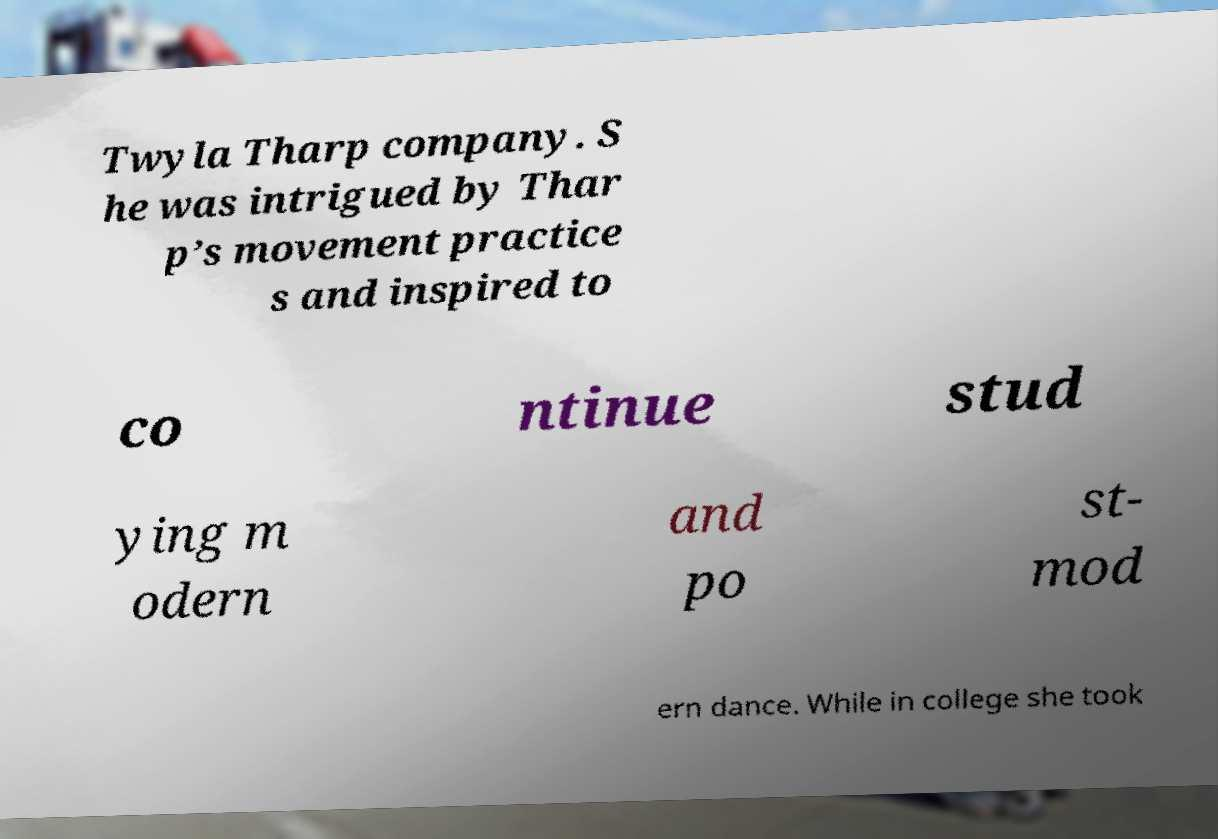Can you accurately transcribe the text from the provided image for me? Twyla Tharp company. S he was intrigued by Thar p’s movement practice s and inspired to co ntinue stud ying m odern and po st- mod ern dance. While in college she took 